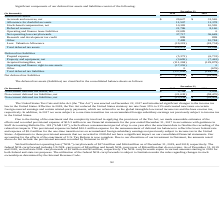According to Allscripts Healthcare Solutions's financial document, When was United States Tax Cuts and Jobs Act (the “Tax Act”) enacted? According to the financial document, December 22, 2017. The relevant text states: "Cuts and Jobs Act (the “Tax Act”) was enacted on December 22, 2017 and introduced significant changes to the income tax..." Also, What is the Allowance for doubtful accounts in 2019? According to the financial document, 11,507. The relevant text states: "Allowance for doubtful accounts 11,507 11,378..." Also, How much was the federal net operating loss (“NOL”) carryforwards as of December 31, 2019, and 2018 respectively? The document shows two values: $174 million and $164 million. From the document: "ederal net operating loss (“NOL”) carryforwards of $174 million and $164 million as of December 31, 2019, and 2018, respectively. The ing loss (“NOL”)..." Also, can you calculate: What is the change in Accruals and reserves, net between 2019 and 2018? Based on the calculation: 29,627-31,565, the result is -1938 (in thousands). This is based on the information: "Accruals and reserves, net $ 29,627 $ 31,565 Accruals and reserves, net $ 29,627 $ 31,565..." The key data points involved are: 29,627, 31,565. Also, can you calculate: What is the change in Allowance for doubtful accounts between 2019 and 2018? Based on the calculation: 11,507-11,378, the result is 129 (in thousands). This is based on the information: "Allowance for doubtful accounts 11,507 11,378 Allowance for doubtful accounts 11,507 11,378..." The key data points involved are: 11,378, 11,507. Also, can you calculate: What is the change in Stock-based compensation, net between 2019 and 2018? Based on the calculation: 10,382-10,595, the result is -213 (in thousands). This is based on the information: "Stock-based compensation, net 10,382 10,595 Stock-based compensation, net 10,382 10,595..." The key data points involved are: 10,382, 10,595. 